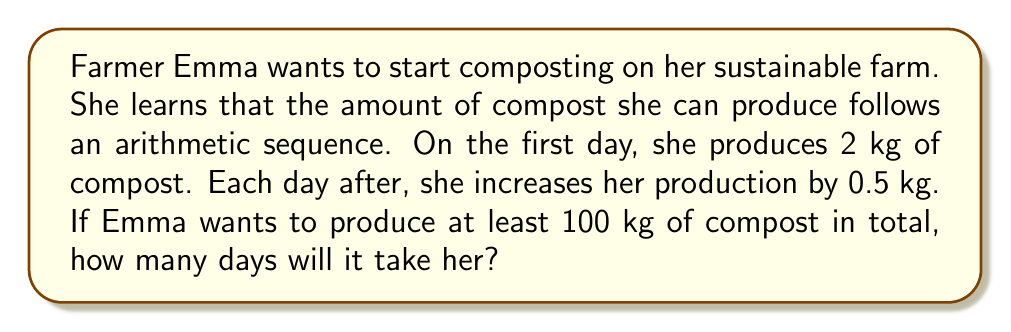Could you help me with this problem? Let's approach this step-by-step using arithmetic sequences:

1) First, we identify the components of our arithmetic sequence:
   $a_1 = 2$ (first term)
   $d = 0.5$ (common difference)

2) We need to find $n$ (number of days) such that the sum of the sequence is at least 100 kg.

3) The formula for the sum of an arithmetic sequence is:
   $$S_n = \frac{n}{2}(a_1 + a_n)$$
   where $a_n$ is the last term.

4) We also know that in an arithmetic sequence:
   $$a_n = a_1 + (n-1)d$$

5) Substituting this into our sum formula:
   $$S_n = \frac{n}{2}(a_1 + [a_1 + (n-1)d])$$
   $$S_n = \frac{n}{2}(2a_1 + (n-1)d)$$

6) Now, let's substitute our known values:
   $$100 \leq \frac{n}{2}(2(2) + (n-1)(0.5))$$
   $$100 \leq \frac{n}{2}(4 + 0.5n - 0.5)$$
   $$100 \leq \frac{n}{2}(3.5 + 0.5n)$$

7) Multiply both sides by 2:
   $$200 \leq n(3.5 + 0.5n)$$

8) Expand:
   $$200 \leq 3.5n + 0.5n^2$$

9) Rearrange to standard quadratic form:
   $$0.5n^2 + 3.5n - 200 \geq 0$$

10) We can solve this using the quadratic formula, but since we're looking for the smallest integer n that satisfies this inequality, we can test values:

    For n = 13: $0.5(13)^2 + 3.5(13) - 200 = 180.25 < 0$
    For n = 14: $0.5(14)^2 + 3.5(14) - 200 = 203 > 0$

Therefore, it will take 14 days to produce at least 100 kg of compost.
Answer: 14 days 